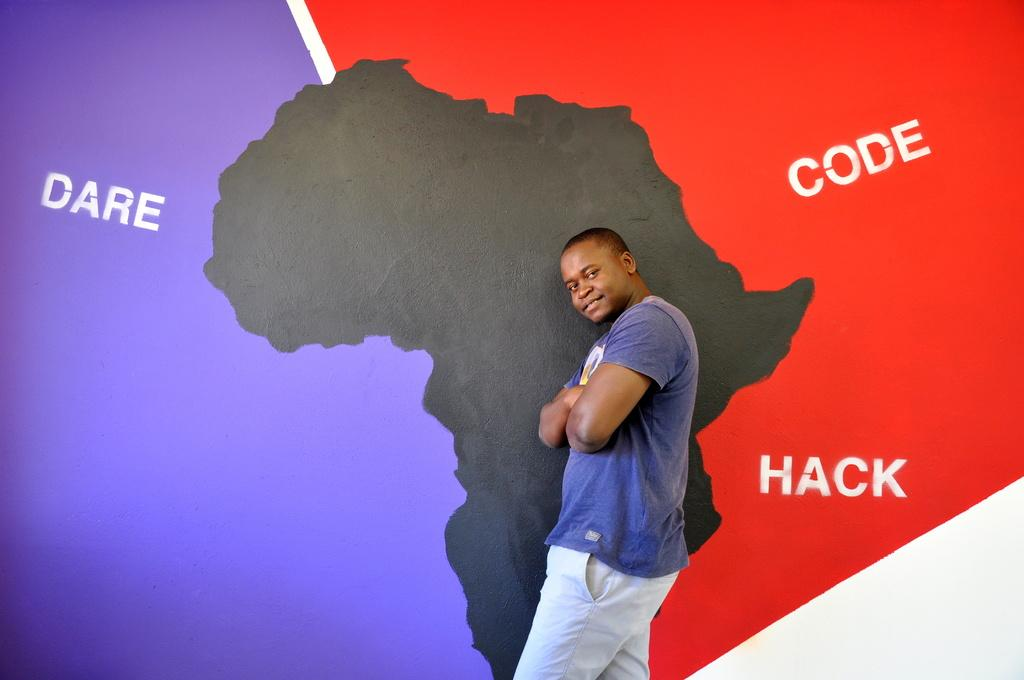Provide a one-sentence caption for the provided image. A guy in front of a picture of africa and the words Dare, code, and hack. 